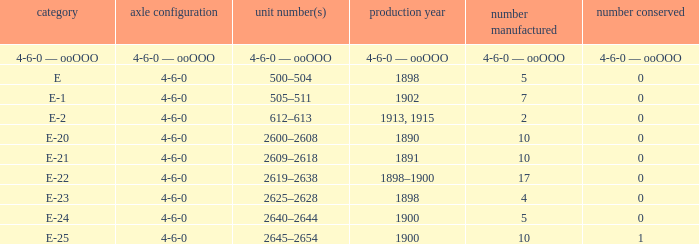What is the wheel arrangement made in 1890? 4-6-0. 